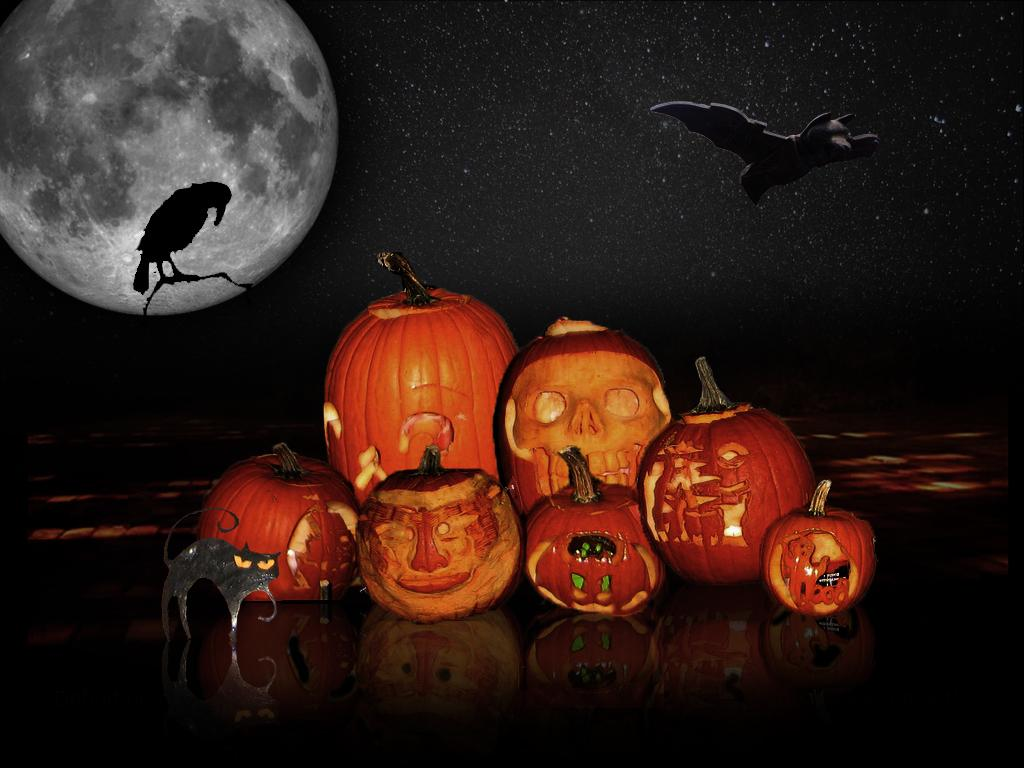What type of objects are present in the image? There are pumpkins in the image. What can be seen in the background of the image? There is a moon visible in the background of the image, along with animal-shaped objects. How would you describe the lighting in the image? The background of the image is dark. What type of loaf is being used to carve the end of the pumpkin in the image? There is no loaf or carving activity present in the image; it features pumpkins and a dark background with a moon and animal-shaped objects. 